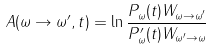<formula> <loc_0><loc_0><loc_500><loc_500>A ( \omega \to \omega ^ { \prime } , t ) = \ln \frac { P _ { \omega } ( t ) W _ { \omega \to \omega ^ { \prime } } } { P _ { \omega } ^ { \prime } ( t ) W _ { \omega ^ { \prime } \to \omega } }</formula> 